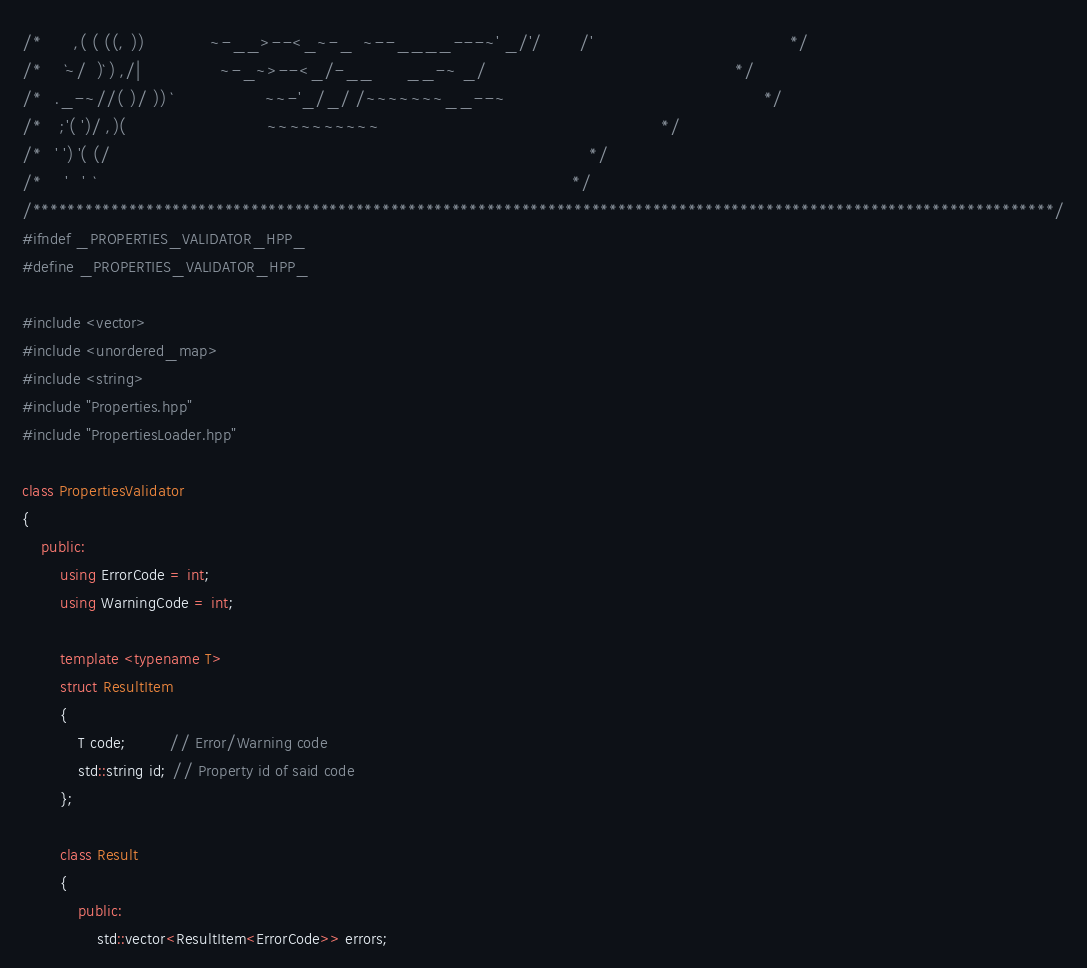Convert code to text. <code><loc_0><loc_0><loc_500><loc_500><_C++_>/*       ,( ( ((, ))              ~-__>--<_~-_  ~--____---~' _/'/        /'                                          */
/*     `~/  )` ) ,/|                 ~-_~>--<_/-__       __-~ _/                                                     */
/*   ._-~//( )/ )) `                    ~~-'_/_/ /~~~~~~~__--~                                                       */
/*    ;'( ')/ ,)(                              ~~~~~~~~~~                                                            */
/*   ' ') '( (/                                                                                                      */
/*     '   '  `                                                                                                      */
/*********************************************************************************************************************/
#ifndef _PROPERTIES_VALIDATOR_HPP_
#define _PROPERTIES_VALIDATOR_HPP_

#include <vector>
#include <unordered_map>
#include <string>
#include "Properties.hpp"
#include "PropertiesLoader.hpp"

class PropertiesValidator
{
    public:
        using ErrorCode = int;
        using WarningCode = int;

        template <typename T>
        struct ResultItem
        {
            T code;         // Error/Warning code
            std::string id; // Property id of said code
        };

        class Result
        {
            public:
                std::vector<ResultItem<ErrorCode>> errors;</code> 